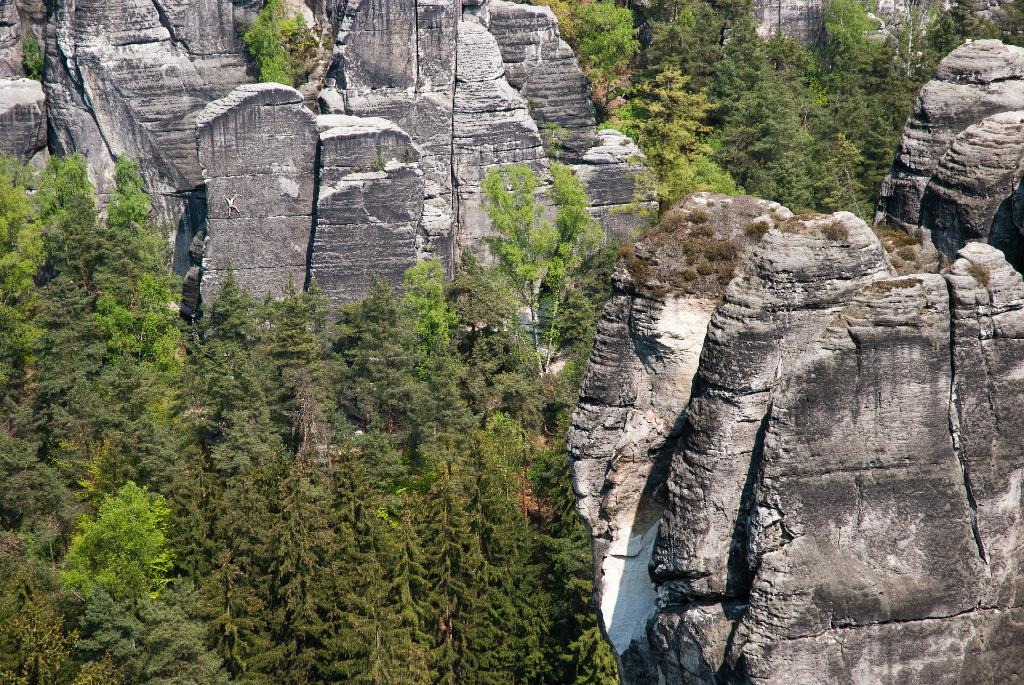What is the main feature in the foreground of the image? There are many trees and cliffs in the foreground of the image. Can you describe the vegetation in the image? The image features many trees in the foreground. What type of geological formation can be seen in the image? Cliffs are visible in the foreground of the image. What time of day is depicted in the image? The provided facts do not mention the time of day, so it cannot be determined from the image. Can you tell me how many donkeys are present in the image? There are no donkeys present in the image. 